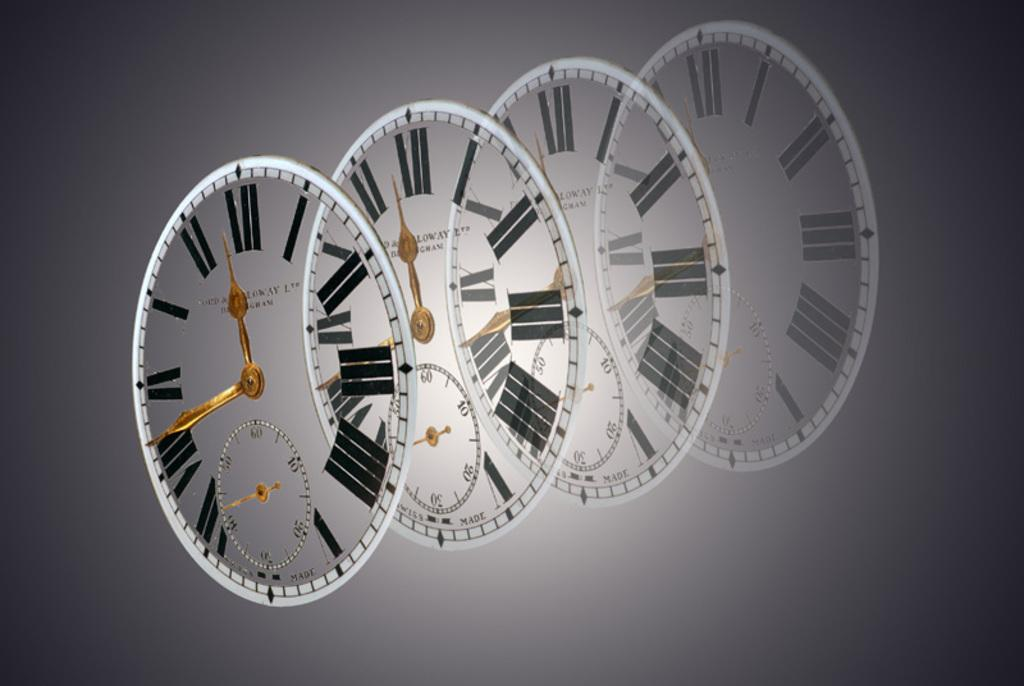<image>
Present a compact description of the photo's key features. Overlays of clock faces that say "swiss made" at the bottom are shown on a gray background. 